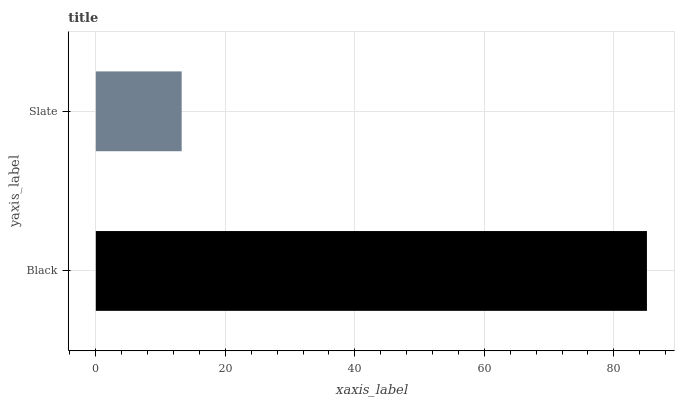Is Slate the minimum?
Answer yes or no. Yes. Is Black the maximum?
Answer yes or no. Yes. Is Slate the maximum?
Answer yes or no. No. Is Black greater than Slate?
Answer yes or no. Yes. Is Slate less than Black?
Answer yes or no. Yes. Is Slate greater than Black?
Answer yes or no. No. Is Black less than Slate?
Answer yes or no. No. Is Black the high median?
Answer yes or no. Yes. Is Slate the low median?
Answer yes or no. Yes. Is Slate the high median?
Answer yes or no. No. Is Black the low median?
Answer yes or no. No. 